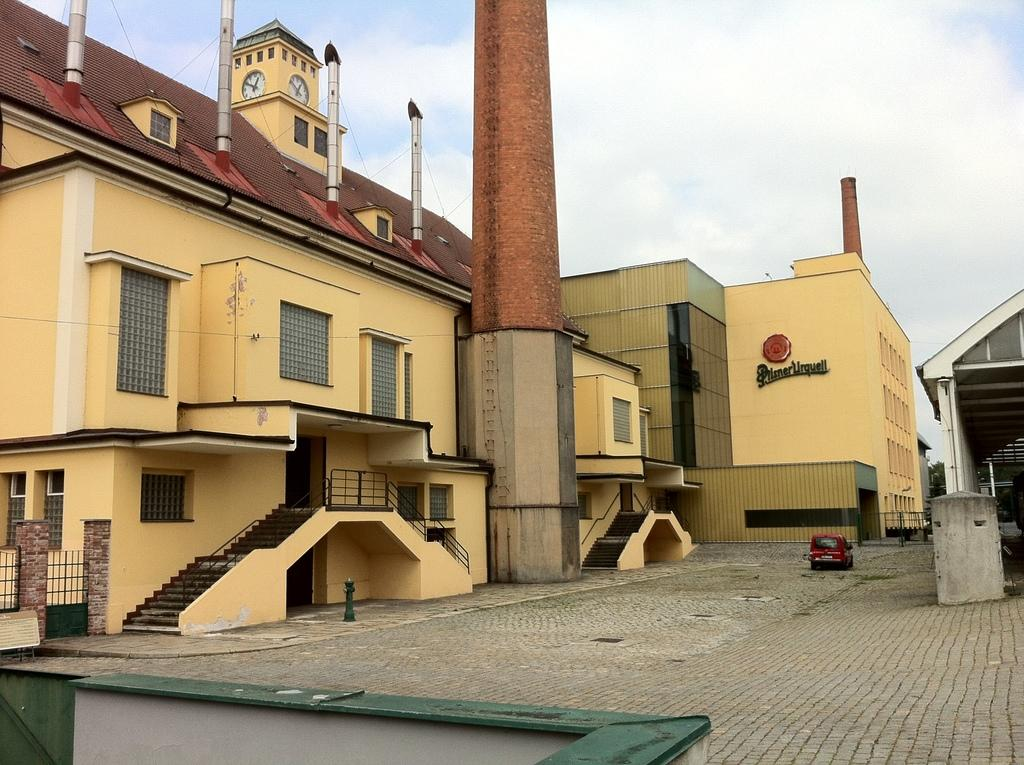What type of structures are depicted in the image? The buildings in the image resemble industries. What feature is present on the rooftops of these structures? The industries have chimneys on their rooftops. Is there any transportation visible in the image? Yes, there is a vehicle visible on the road in the image. What type of lead can be seen being used to support the peace in the image? There is no reference to lead, support, or peace in the image; it features industrial buildings with chimneys and a vehicle on the road. 